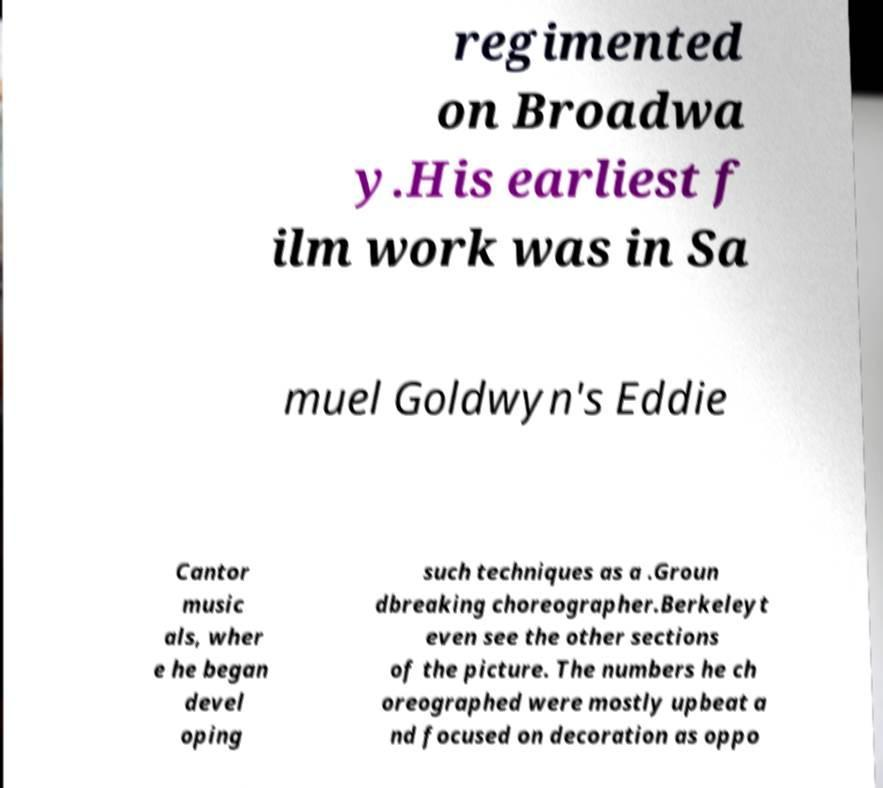Please read and relay the text visible in this image. What does it say? regimented on Broadwa y.His earliest f ilm work was in Sa muel Goldwyn's Eddie Cantor music als, wher e he began devel oping such techniques as a .Groun dbreaking choreographer.Berkeleyt even see the other sections of the picture. The numbers he ch oreographed were mostly upbeat a nd focused on decoration as oppo 